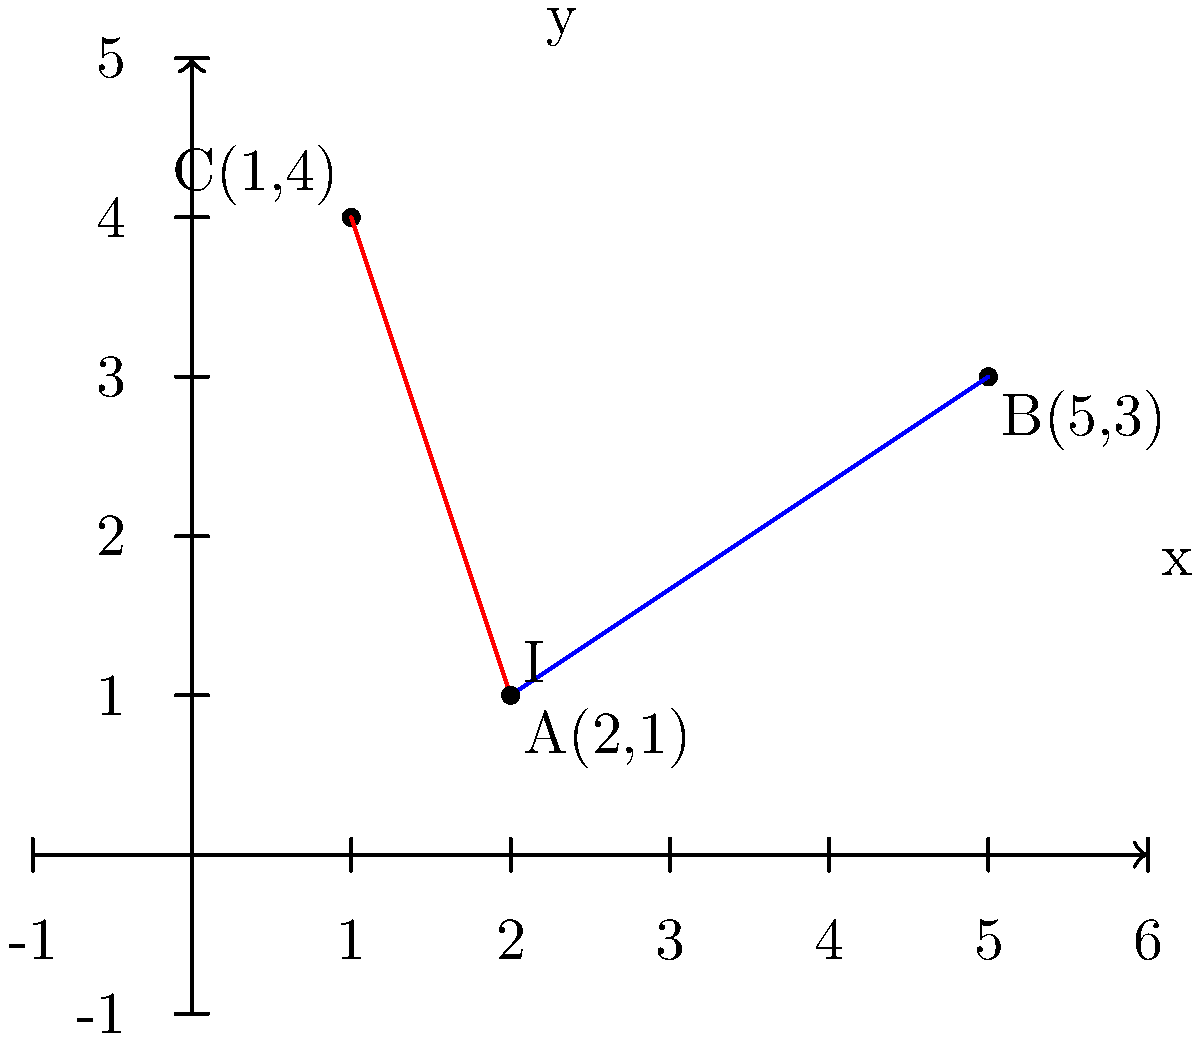In a crime scene investigation, two witnesses observed a suspect from different locations. Witness 1 was at point A(2,1) and saw the suspect along the line extending to B(5,3). Witness 2 was at point A(2,1) and saw the suspect along the line extending to C(1,4). Determine the coordinates of the intersection point I, which represents the suspect's likely location. Round your answer to two decimal places. To find the intersection point of the two witness sightlines, we need to:

1. Find the equations of both lines
2. Solve the system of equations to find the intersection point

Step 1: Find the equations of both lines

Line AB:
Slope $m_{AB} = \frac{y_B - y_A}{x_B - x_A} = \frac{3-1}{5-2} = \frac{2}{3}$
Equation: $y - y_A = m_{AB}(x - x_A)$
$y - 1 = \frac{2}{3}(x - 2)$
$y = \frac{2}{3}x - \frac{1}{3}$

Line AC:
Slope $m_{AC} = \frac{y_C - y_A}{x_C - x_A} = \frac{4-1}{1-2} = -3$
Equation: $y - y_A = m_{AC}(x - x_A)$
$y - 1 = -3(x - 2)$
$y = -3x + 7$

Step 2: Solve the system of equations

$\frac{2}{3}x - \frac{1}{3} = -3x + 7$
$\frac{2}{3}x + 3x = 7 + \frac{1}{3}$
$\frac{11}{3}x = \frac{22}{3}$
$x = 2$

Substitute $x = 2$ into either equation:
$y = \frac{2}{3}(2) - \frac{1}{3} = 1$

Therefore, the intersection point I has coordinates (2, 1).
Answer: (2.00, 1.00) 